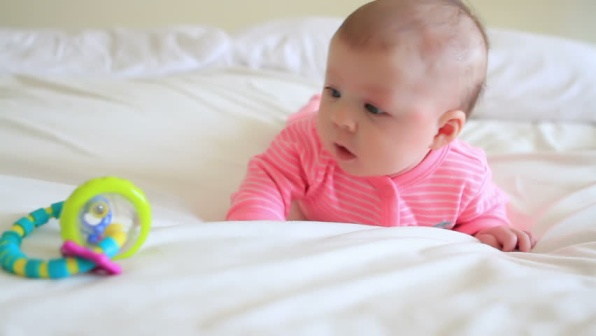Can you tell a story about a playful adventure involving the baby and the toy? Once upon a time, in the quiet comforts of a cozy bedroom, a curious baby discovered a magical rattle. As the baby reached out to grasp the vibrant toy, it began to glow with a soft, enchanting light. Suddenly, the baby and the toy were whisked away to a wondrous land filled with colors and sounds. Together, they embarked on an adventure, meeting friendly creatures and exploring enchanting forests. The rattle jingled with every step, guiding the baby through this magical world. By the end of the day, the baby had made many new friends and learned about the amazing wonders of this fantastical place. Exhausted but happy, the baby and the rattle returned to the bedroom, where they lay peacefully, dreaming of more adventures to come. What kind of adventures do you think the baby will have with the rattle in the future? In the future, the baby and the rattle might discover a garden where every flower plays a different musical note when touched. They could also visit a dreamland populated by friendly animals like talking rabbits and singing birds, each teaching the baby a new skill or game. Perhaps they'll embark on a treasure hunt, finding hidden keys and unlocking mysteries of an ancient kingdom. The possibilities are endless, and each adventure promises to be filled with fun, learning, and the magic of discovery. 